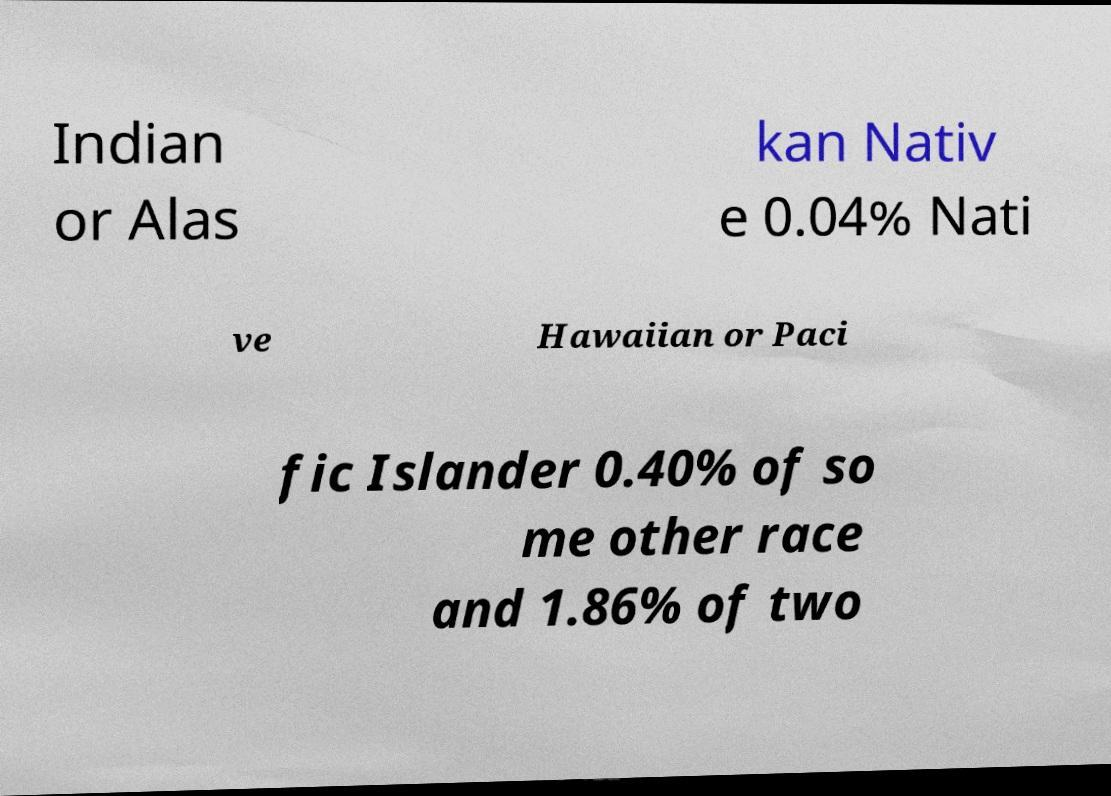Could you extract and type out the text from this image? Indian or Alas kan Nativ e 0.04% Nati ve Hawaiian or Paci fic Islander 0.40% of so me other race and 1.86% of two 